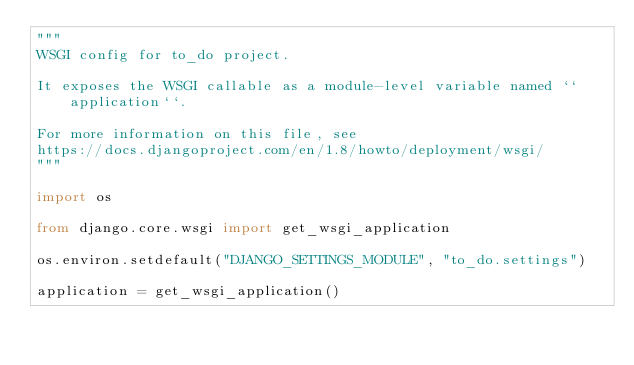<code> <loc_0><loc_0><loc_500><loc_500><_Python_>"""
WSGI config for to_do project.

It exposes the WSGI callable as a module-level variable named ``application``.

For more information on this file, see
https://docs.djangoproject.com/en/1.8/howto/deployment/wsgi/
"""

import os

from django.core.wsgi import get_wsgi_application

os.environ.setdefault("DJANGO_SETTINGS_MODULE", "to_do.settings")

application = get_wsgi_application()
</code> 